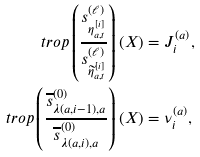Convert formula to latex. <formula><loc_0><loc_0><loc_500><loc_500>\ t r o p \left ( \frac { s ^ { ( \ell ) } _ { \eta _ { a , t } ^ { [ i ] } } } { s ^ { ( \ell ) } _ { \widetilde { \eta } _ { a , t } ^ { [ i ] } } } \right ) ( X ) & = J _ { i } ^ { ( a ) } , \\ \ t r o p \left ( \frac { \overline { s } ^ { ( 0 ) } _ { \lambda ( a , i - 1 ) , a } } { \overline { s } ^ { ( 0 ) } _ { \lambda ( a , i ) , a } } \right ) ( X ) & = \nu _ { i } ^ { ( a ) } ,</formula> 